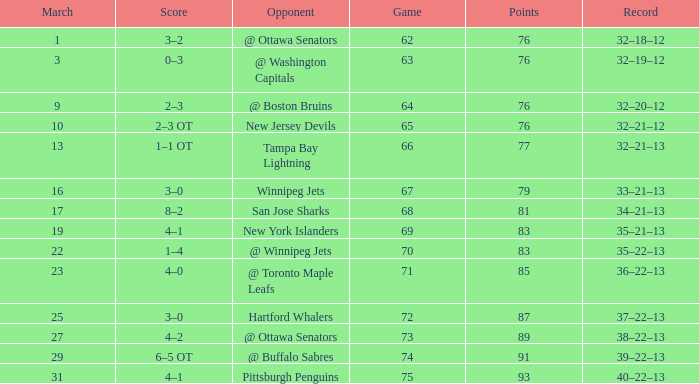How many games have a March of 19, and Points smaller than 83? 0.0. 